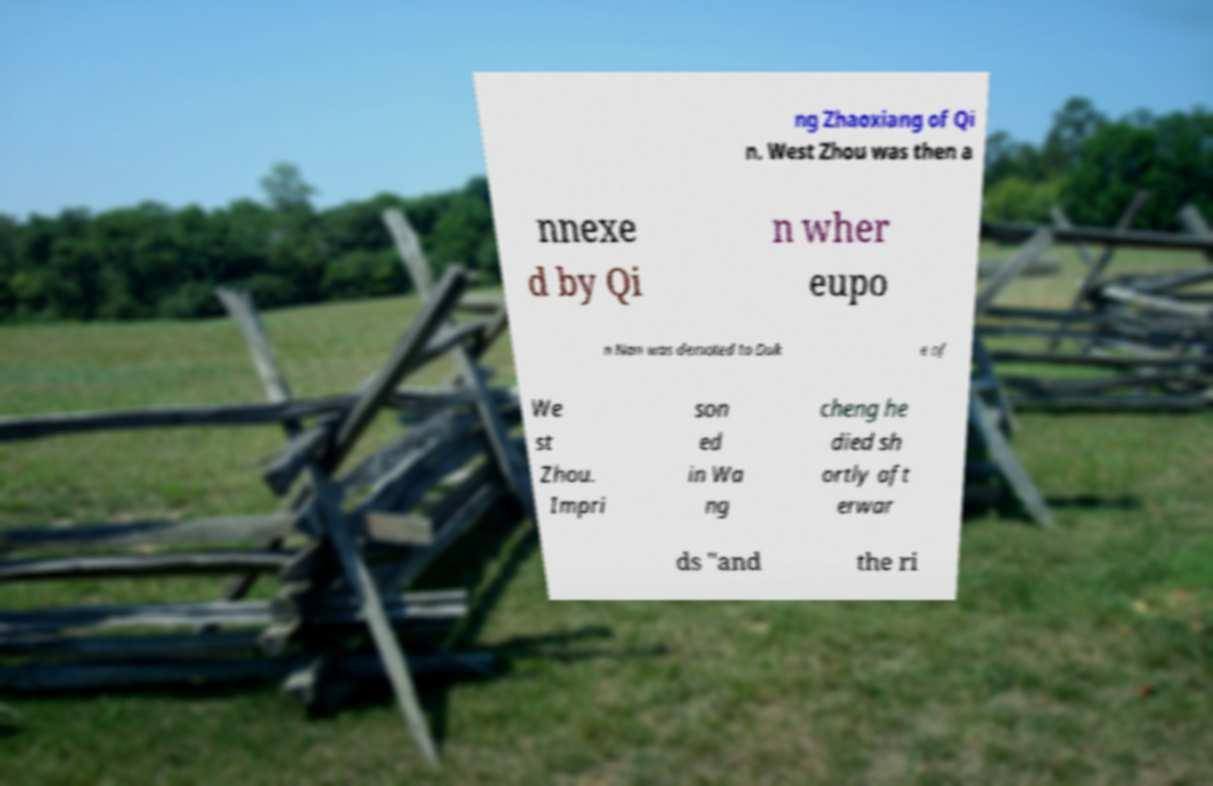Could you assist in decoding the text presented in this image and type it out clearly? ng Zhaoxiang of Qi n. West Zhou was then a nnexe d by Qi n wher eupo n Nan was demoted to Duk e of We st Zhou. Impri son ed in Wa ng cheng he died sh ortly aft erwar ds "and the ri 